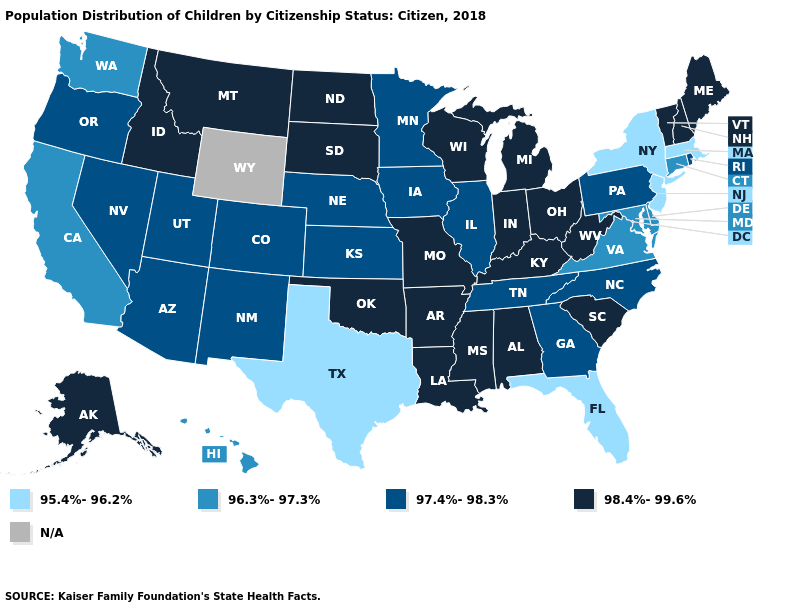What is the value of Arkansas?
Give a very brief answer. 98.4%-99.6%. What is the value of Washington?
Concise answer only. 96.3%-97.3%. Does Alaska have the highest value in the USA?
Answer briefly. Yes. What is the highest value in the MidWest ?
Short answer required. 98.4%-99.6%. Does the map have missing data?
Be succinct. Yes. Among the states that border Indiana , which have the highest value?
Concise answer only. Kentucky, Michigan, Ohio. Among the states that border Delaware , does Pennsylvania have the highest value?
Short answer required. Yes. Name the states that have a value in the range 95.4%-96.2%?
Keep it brief. Florida, Massachusetts, New Jersey, New York, Texas. Name the states that have a value in the range N/A?
Write a very short answer. Wyoming. Name the states that have a value in the range 96.3%-97.3%?
Be succinct. California, Connecticut, Delaware, Hawaii, Maryland, Virginia, Washington. Name the states that have a value in the range 96.3%-97.3%?
Quick response, please. California, Connecticut, Delaware, Hawaii, Maryland, Virginia, Washington. Among the states that border New Mexico , which have the lowest value?
Be succinct. Texas. Name the states that have a value in the range N/A?
Be succinct. Wyoming. Name the states that have a value in the range 96.3%-97.3%?
Quick response, please. California, Connecticut, Delaware, Hawaii, Maryland, Virginia, Washington. 